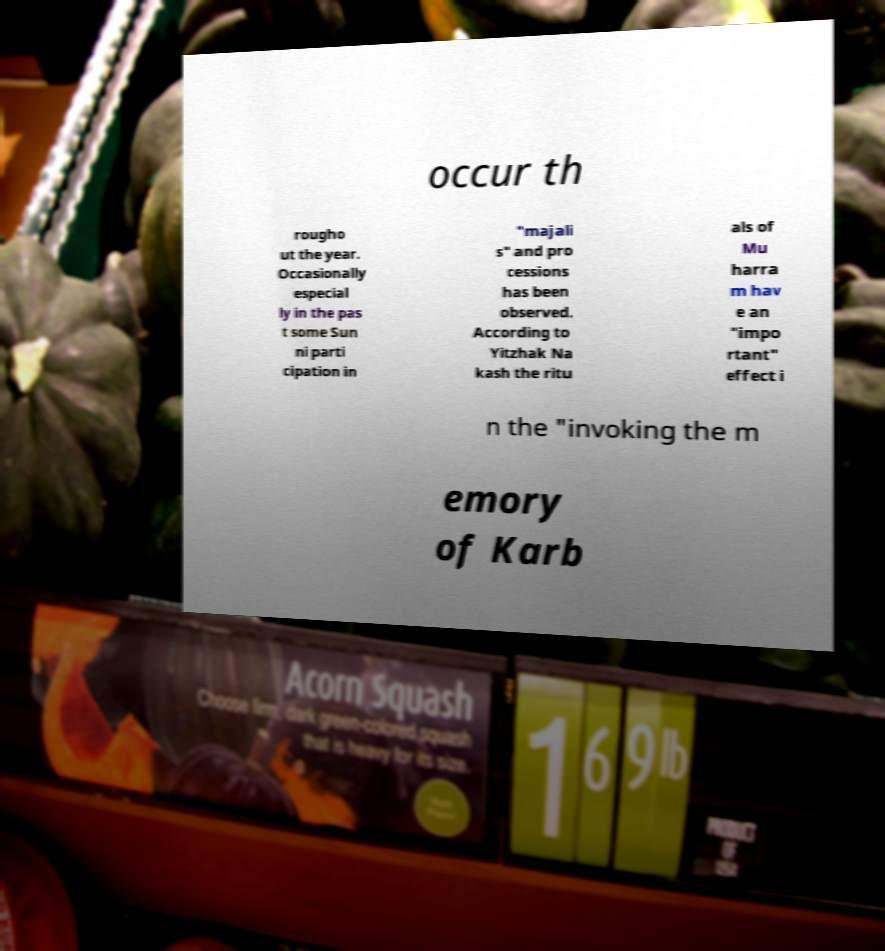Could you assist in decoding the text presented in this image and type it out clearly? occur th rougho ut the year. Occasionally especial ly in the pas t some Sun ni parti cipation in "majali s" and pro cessions has been observed. According to Yitzhak Na kash the ritu als of Mu harra m hav e an "impo rtant" effect i n the "invoking the m emory of Karb 